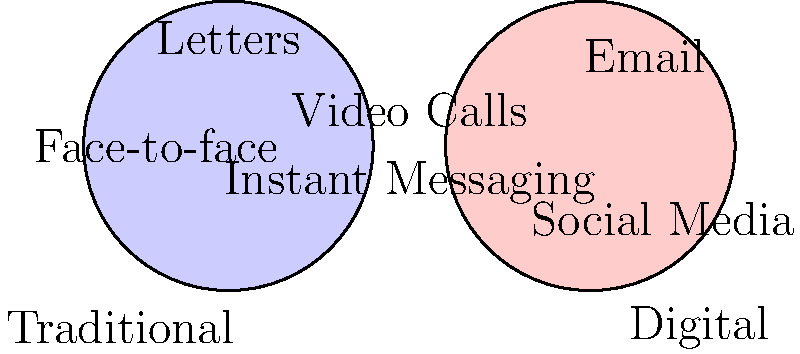In the Venn diagram comparing traditional and digital communication methods, which communication forms are represented in the overlapping area, indicating they can be considered both traditional and digital? To answer this question, we need to analyze the Venn diagram carefully:

1. The left circle represents traditional communication methods, including face-to-face communication and letters.

2. The right circle represents digital communication methods, including email and social media.

3. The overlapping area between the two circles represents communication methods that can be considered both traditional and digital.

4. In this overlapping area, we can see two methods listed:
   a) Video Calls
   b) Instant Messaging

5. These two methods are placed in the intersection because:
   - Video calls combine the traditional aspect of face-to-face communication with digital technology.
   - Instant messaging can be seen as a digital evolution of traditional quick, informal communication methods.

Therefore, the communication forms represented in the overlapping area, indicating they can be considered both traditional and digital, are video calls and instant messaging.
Answer: Video calls and instant messaging 